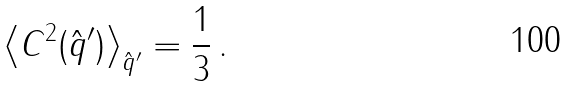<formula> <loc_0><loc_0><loc_500><loc_500>\left \langle C ^ { 2 } ( \hat { q } ^ { \prime } ) \right \rangle _ { \hat { q } ^ { \prime } } = \frac { 1 } { 3 } \, .</formula> 